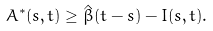Convert formula to latex. <formula><loc_0><loc_0><loc_500><loc_500>A ^ { * } ( s , t ) \geq \hat { \beta } ( t - s ) - I ( s , t ) .</formula> 